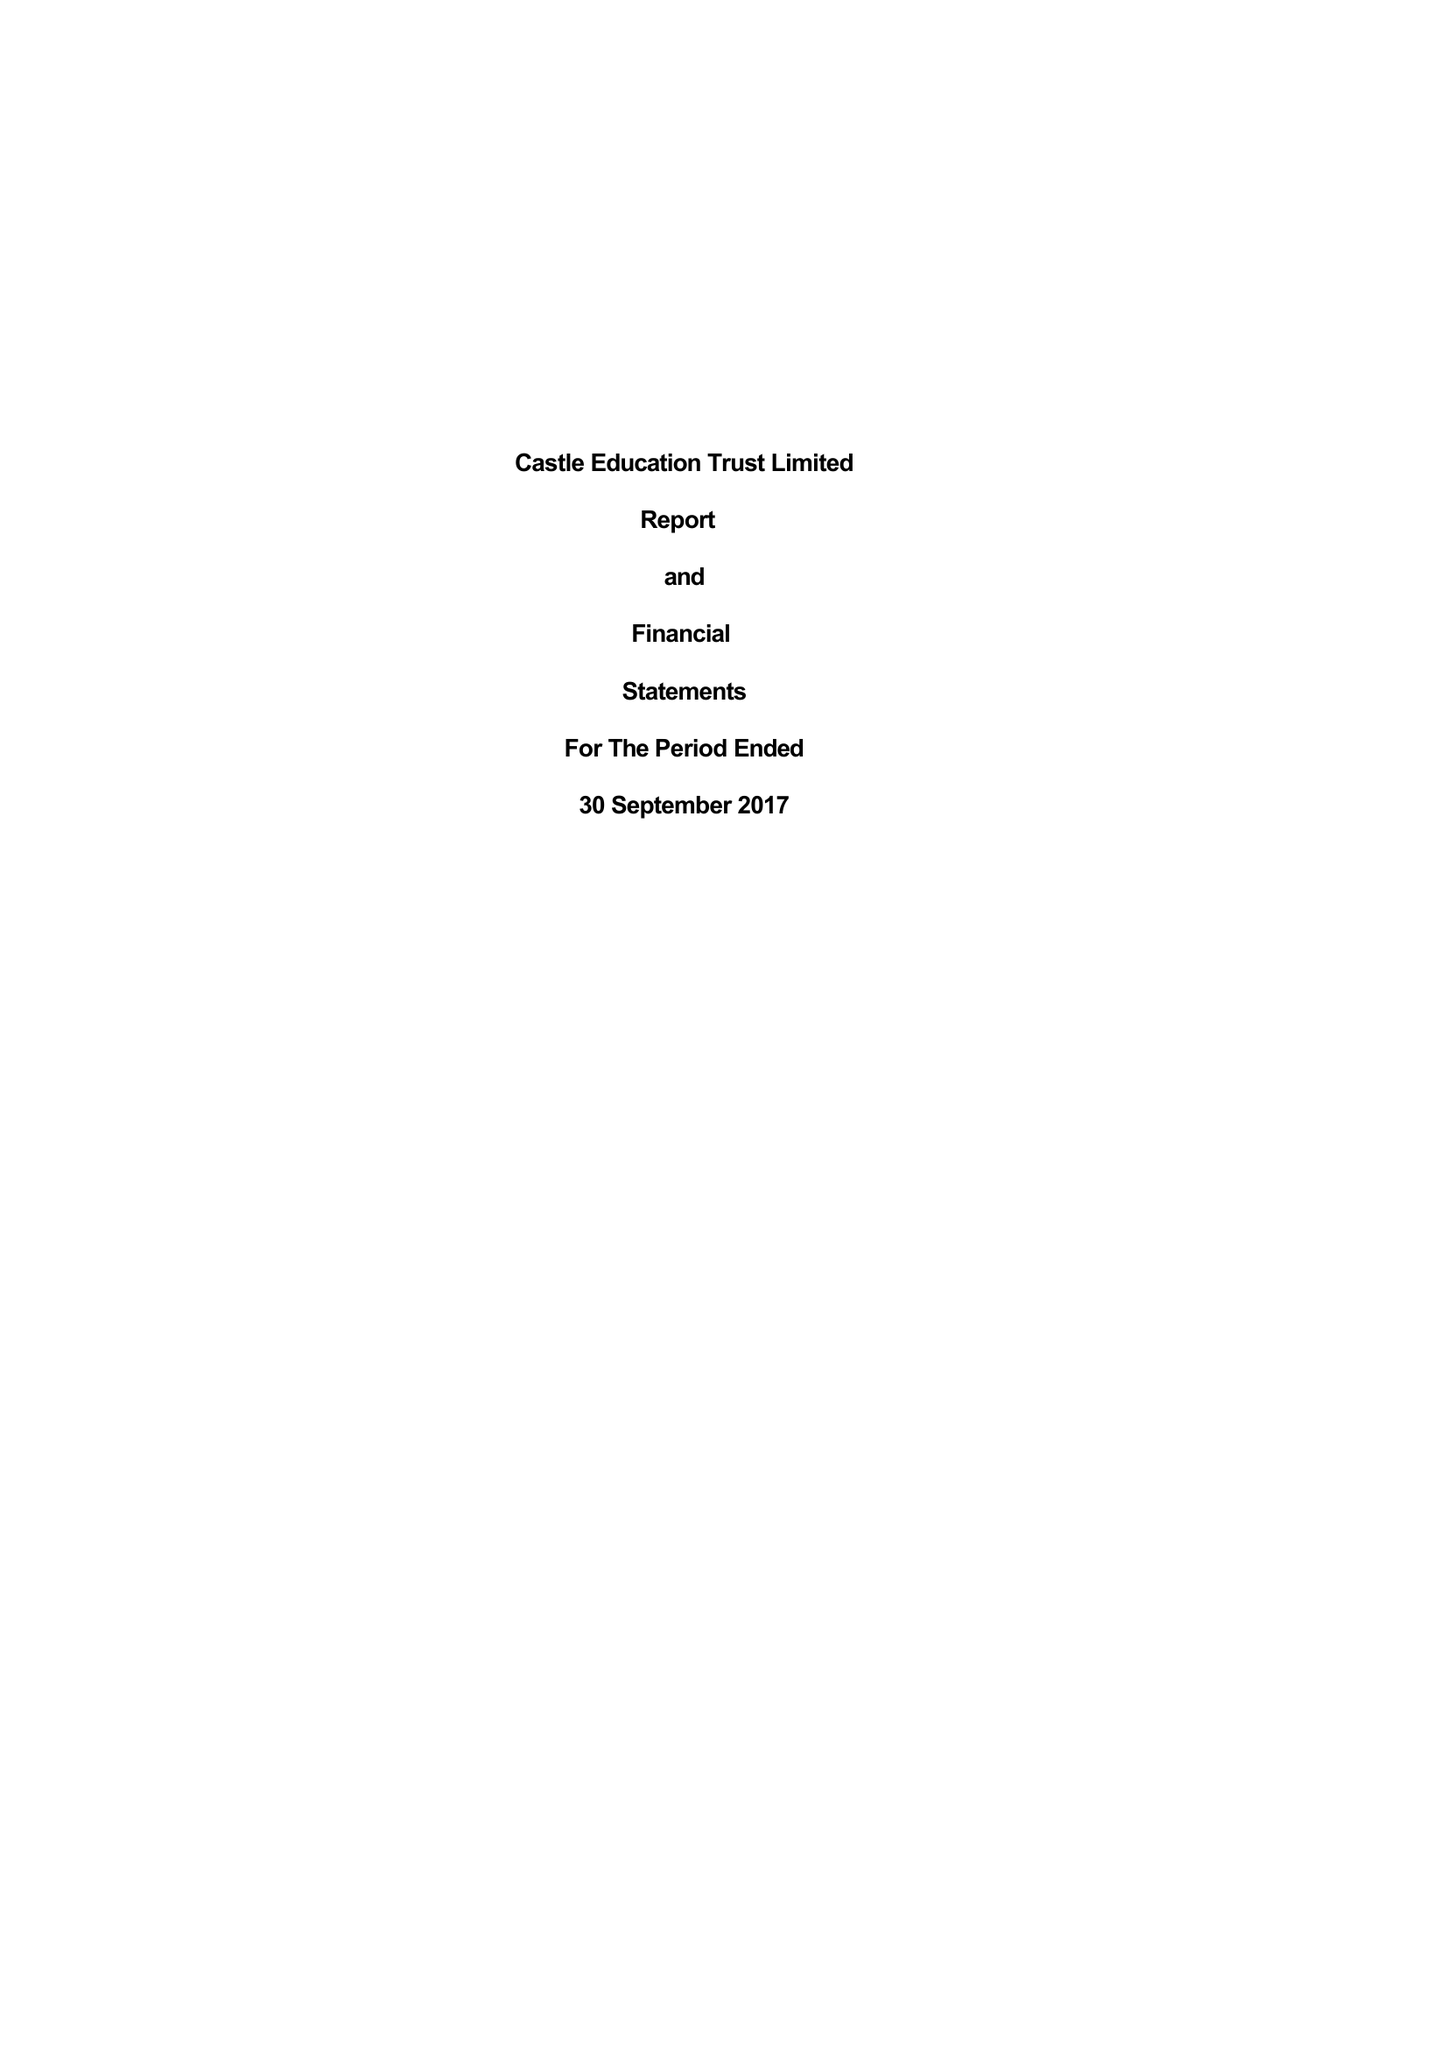What is the value for the address__postcode?
Answer the question using a single word or phrase. N15 6AB 